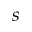<formula> <loc_0><loc_0><loc_500><loc_500>s</formula> 